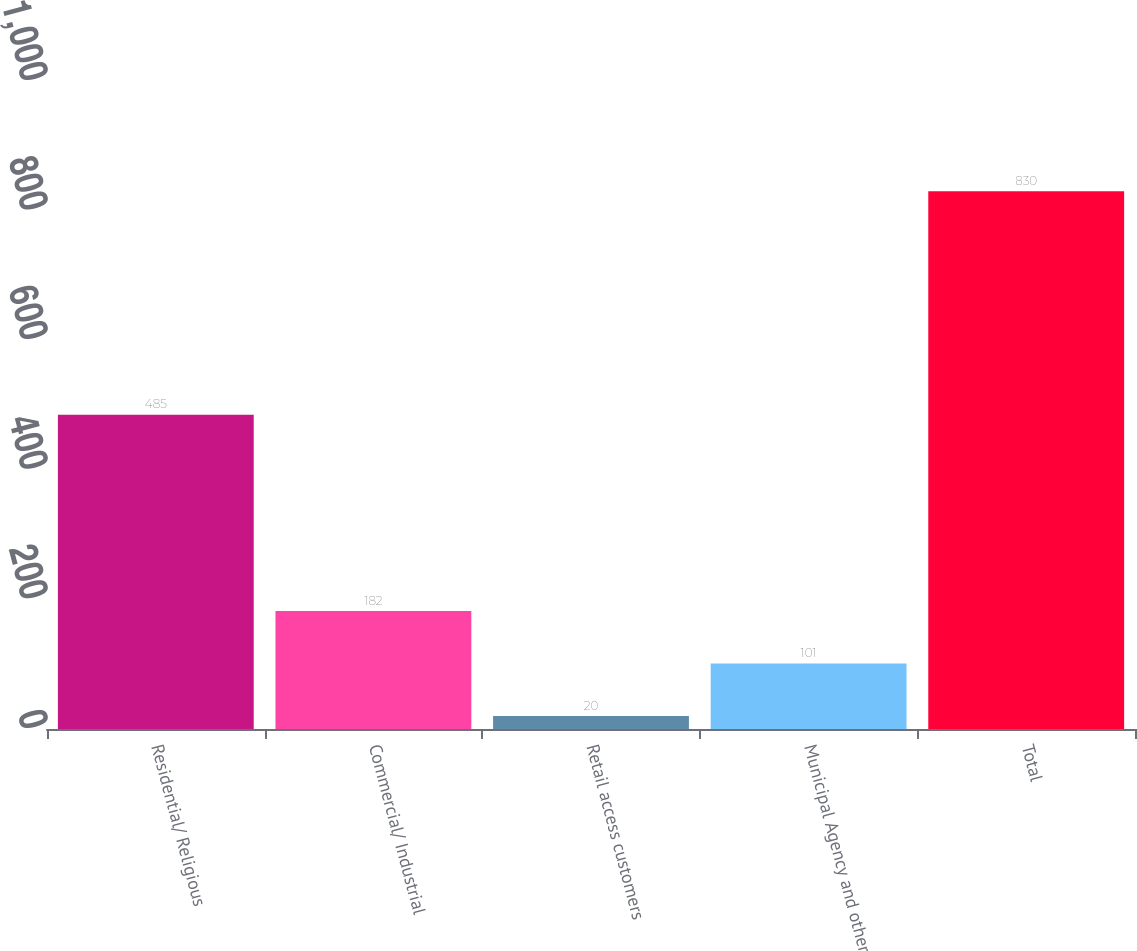Convert chart. <chart><loc_0><loc_0><loc_500><loc_500><bar_chart><fcel>Residential/ Religious<fcel>Commercial/ Industrial<fcel>Retail access customers<fcel>Municipal Agency and other<fcel>Total<nl><fcel>485<fcel>182<fcel>20<fcel>101<fcel>830<nl></chart> 